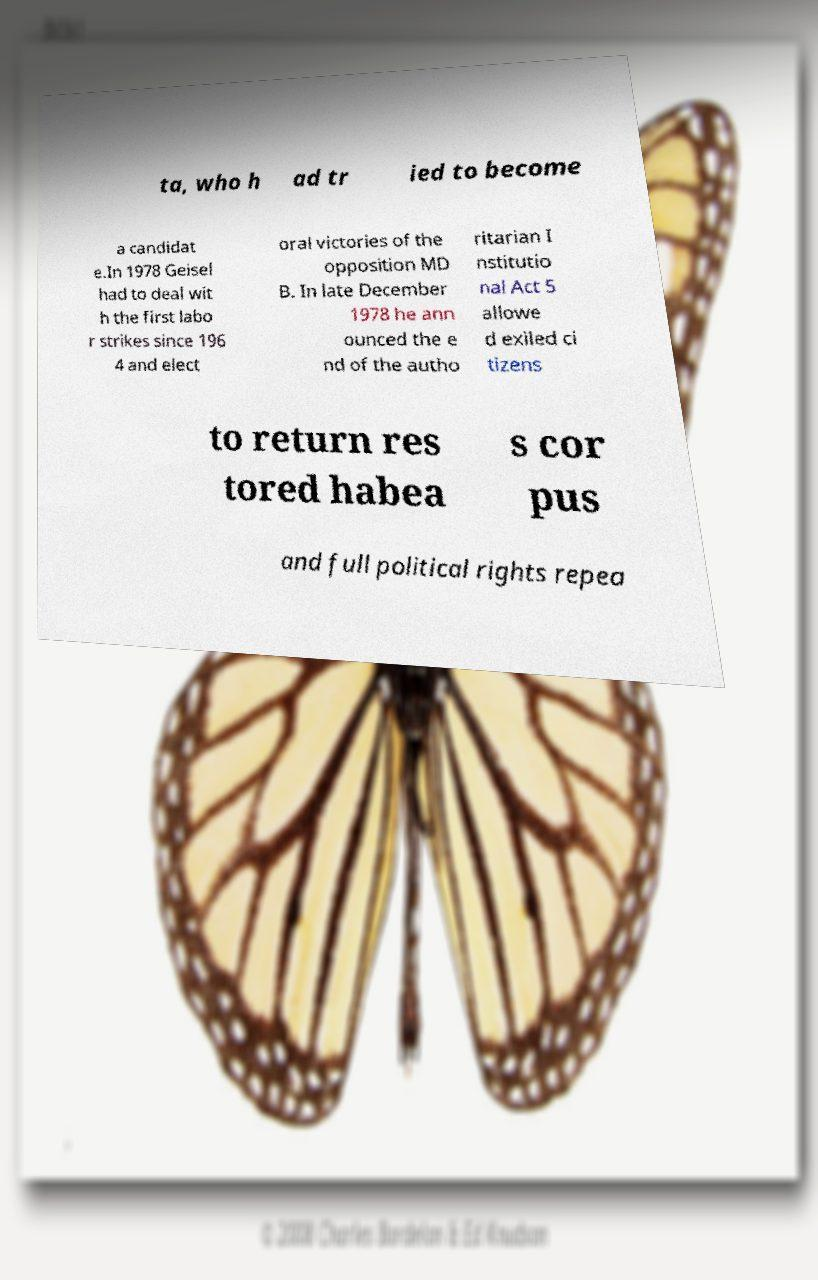I need the written content from this picture converted into text. Can you do that? ta, who h ad tr ied to become a candidat e.In 1978 Geisel had to deal wit h the first labo r strikes since 196 4 and elect oral victories of the opposition MD B. In late December 1978 he ann ounced the e nd of the autho ritarian I nstitutio nal Act 5 allowe d exiled ci tizens to return res tored habea s cor pus and full political rights repea 